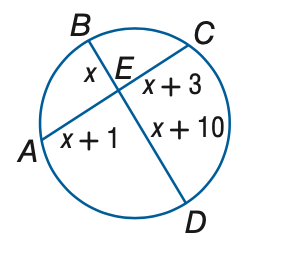Answer the mathemtical geometry problem and directly provide the correct option letter.
Question: Find the measure of x.
Choices: A: 0.5 B: 1.0 C: 1.5 D: 2.0 A 